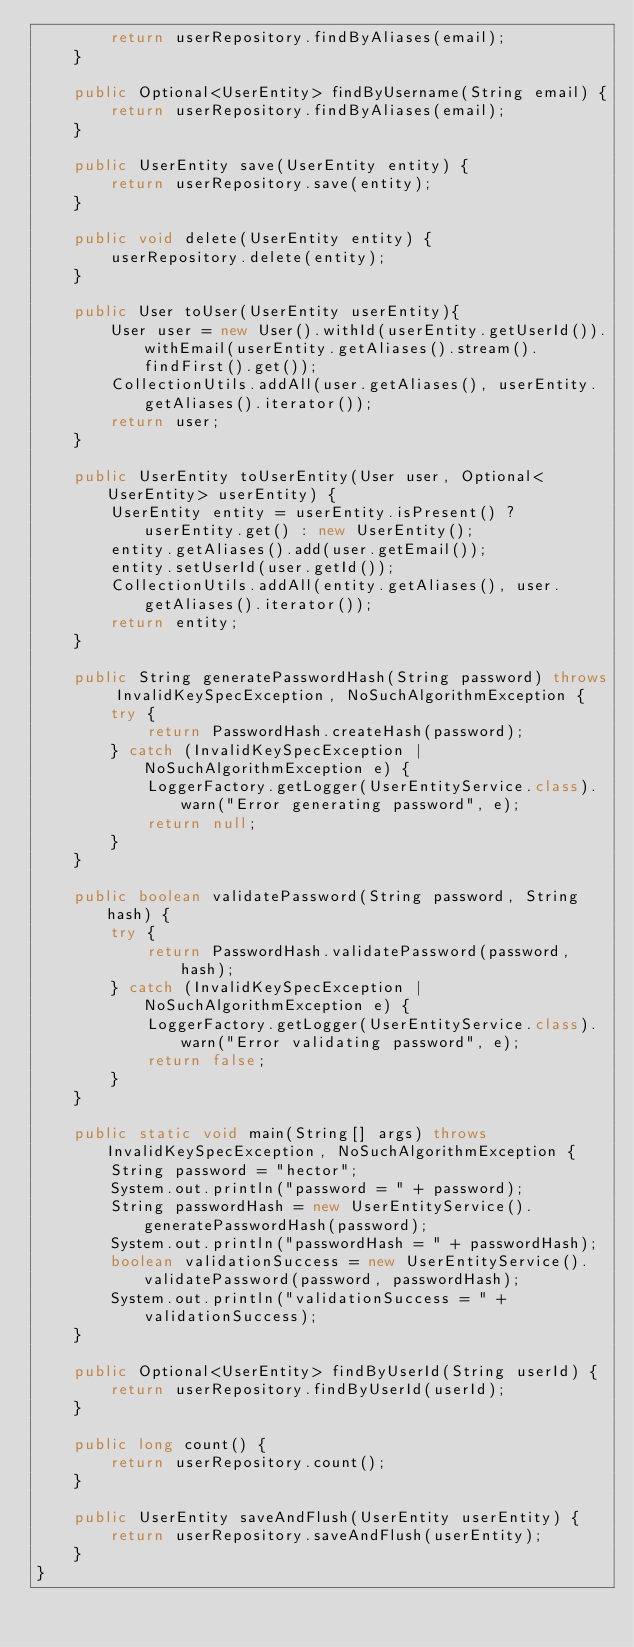<code> <loc_0><loc_0><loc_500><loc_500><_Java_>        return userRepository.findByAliases(email);
    }

    public Optional<UserEntity> findByUsername(String email) {
        return userRepository.findByAliases(email);
    }

    public UserEntity save(UserEntity entity) {
        return userRepository.save(entity);
    }

    public void delete(UserEntity entity) {
        userRepository.delete(entity);
    }

    public User toUser(UserEntity userEntity){
        User user = new User().withId(userEntity.getUserId()).withEmail(userEntity.getAliases().stream().findFirst().get());
        CollectionUtils.addAll(user.getAliases(), userEntity.getAliases().iterator());
        return user;
    }

    public UserEntity toUserEntity(User user, Optional<UserEntity> userEntity) {
        UserEntity entity = userEntity.isPresent() ? userEntity.get() : new UserEntity();
        entity.getAliases().add(user.getEmail());
        entity.setUserId(user.getId());
        CollectionUtils.addAll(entity.getAliases(), user.getAliases().iterator());
        return entity;
    }

    public String generatePasswordHash(String password) throws InvalidKeySpecException, NoSuchAlgorithmException {
        try {
            return PasswordHash.createHash(password);
        } catch (InvalidKeySpecException | NoSuchAlgorithmException e) {
            LoggerFactory.getLogger(UserEntityService.class).warn("Error generating password", e);
            return null;
        }
    }

    public boolean validatePassword(String password, String hash) {
        try {
            return PasswordHash.validatePassword(password, hash);
        } catch (InvalidKeySpecException | NoSuchAlgorithmException e) {
            LoggerFactory.getLogger(UserEntityService.class).warn("Error validating password", e);
            return false;
        }
    }

    public static void main(String[] args) throws InvalidKeySpecException, NoSuchAlgorithmException {
        String password = "hector";
        System.out.println("password = " + password);
        String passwordHash = new UserEntityService().generatePasswordHash(password);
        System.out.println("passwordHash = " + passwordHash);
        boolean validationSuccess = new UserEntityService().validatePassword(password, passwordHash);
        System.out.println("validationSuccess = " + validationSuccess);
    }

    public Optional<UserEntity> findByUserId(String userId) {
        return userRepository.findByUserId(userId);
    }

    public long count() {
        return userRepository.count();
    }

    public UserEntity saveAndFlush(UserEntity userEntity) {
        return userRepository.saveAndFlush(userEntity);
    }
}
</code> 